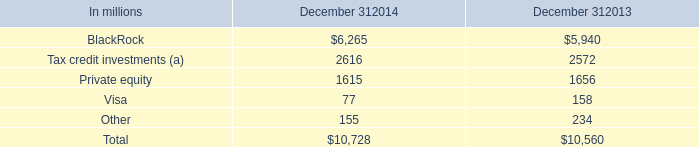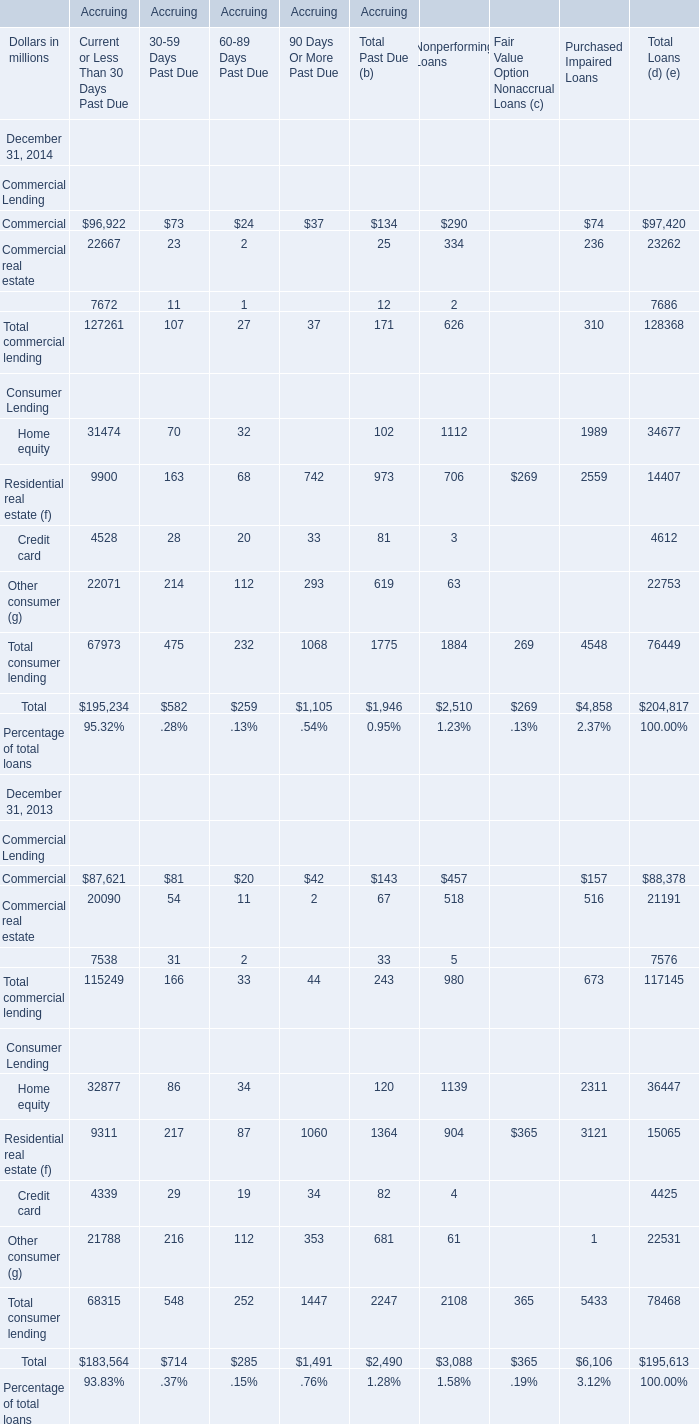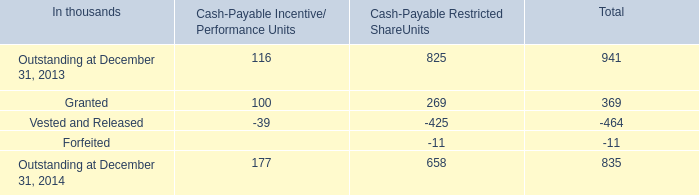What is the value of Total commercial lending for Accruing 90 Days Or More Past Due at December 31, 2014 ? (in million) 
Answer: 37. 